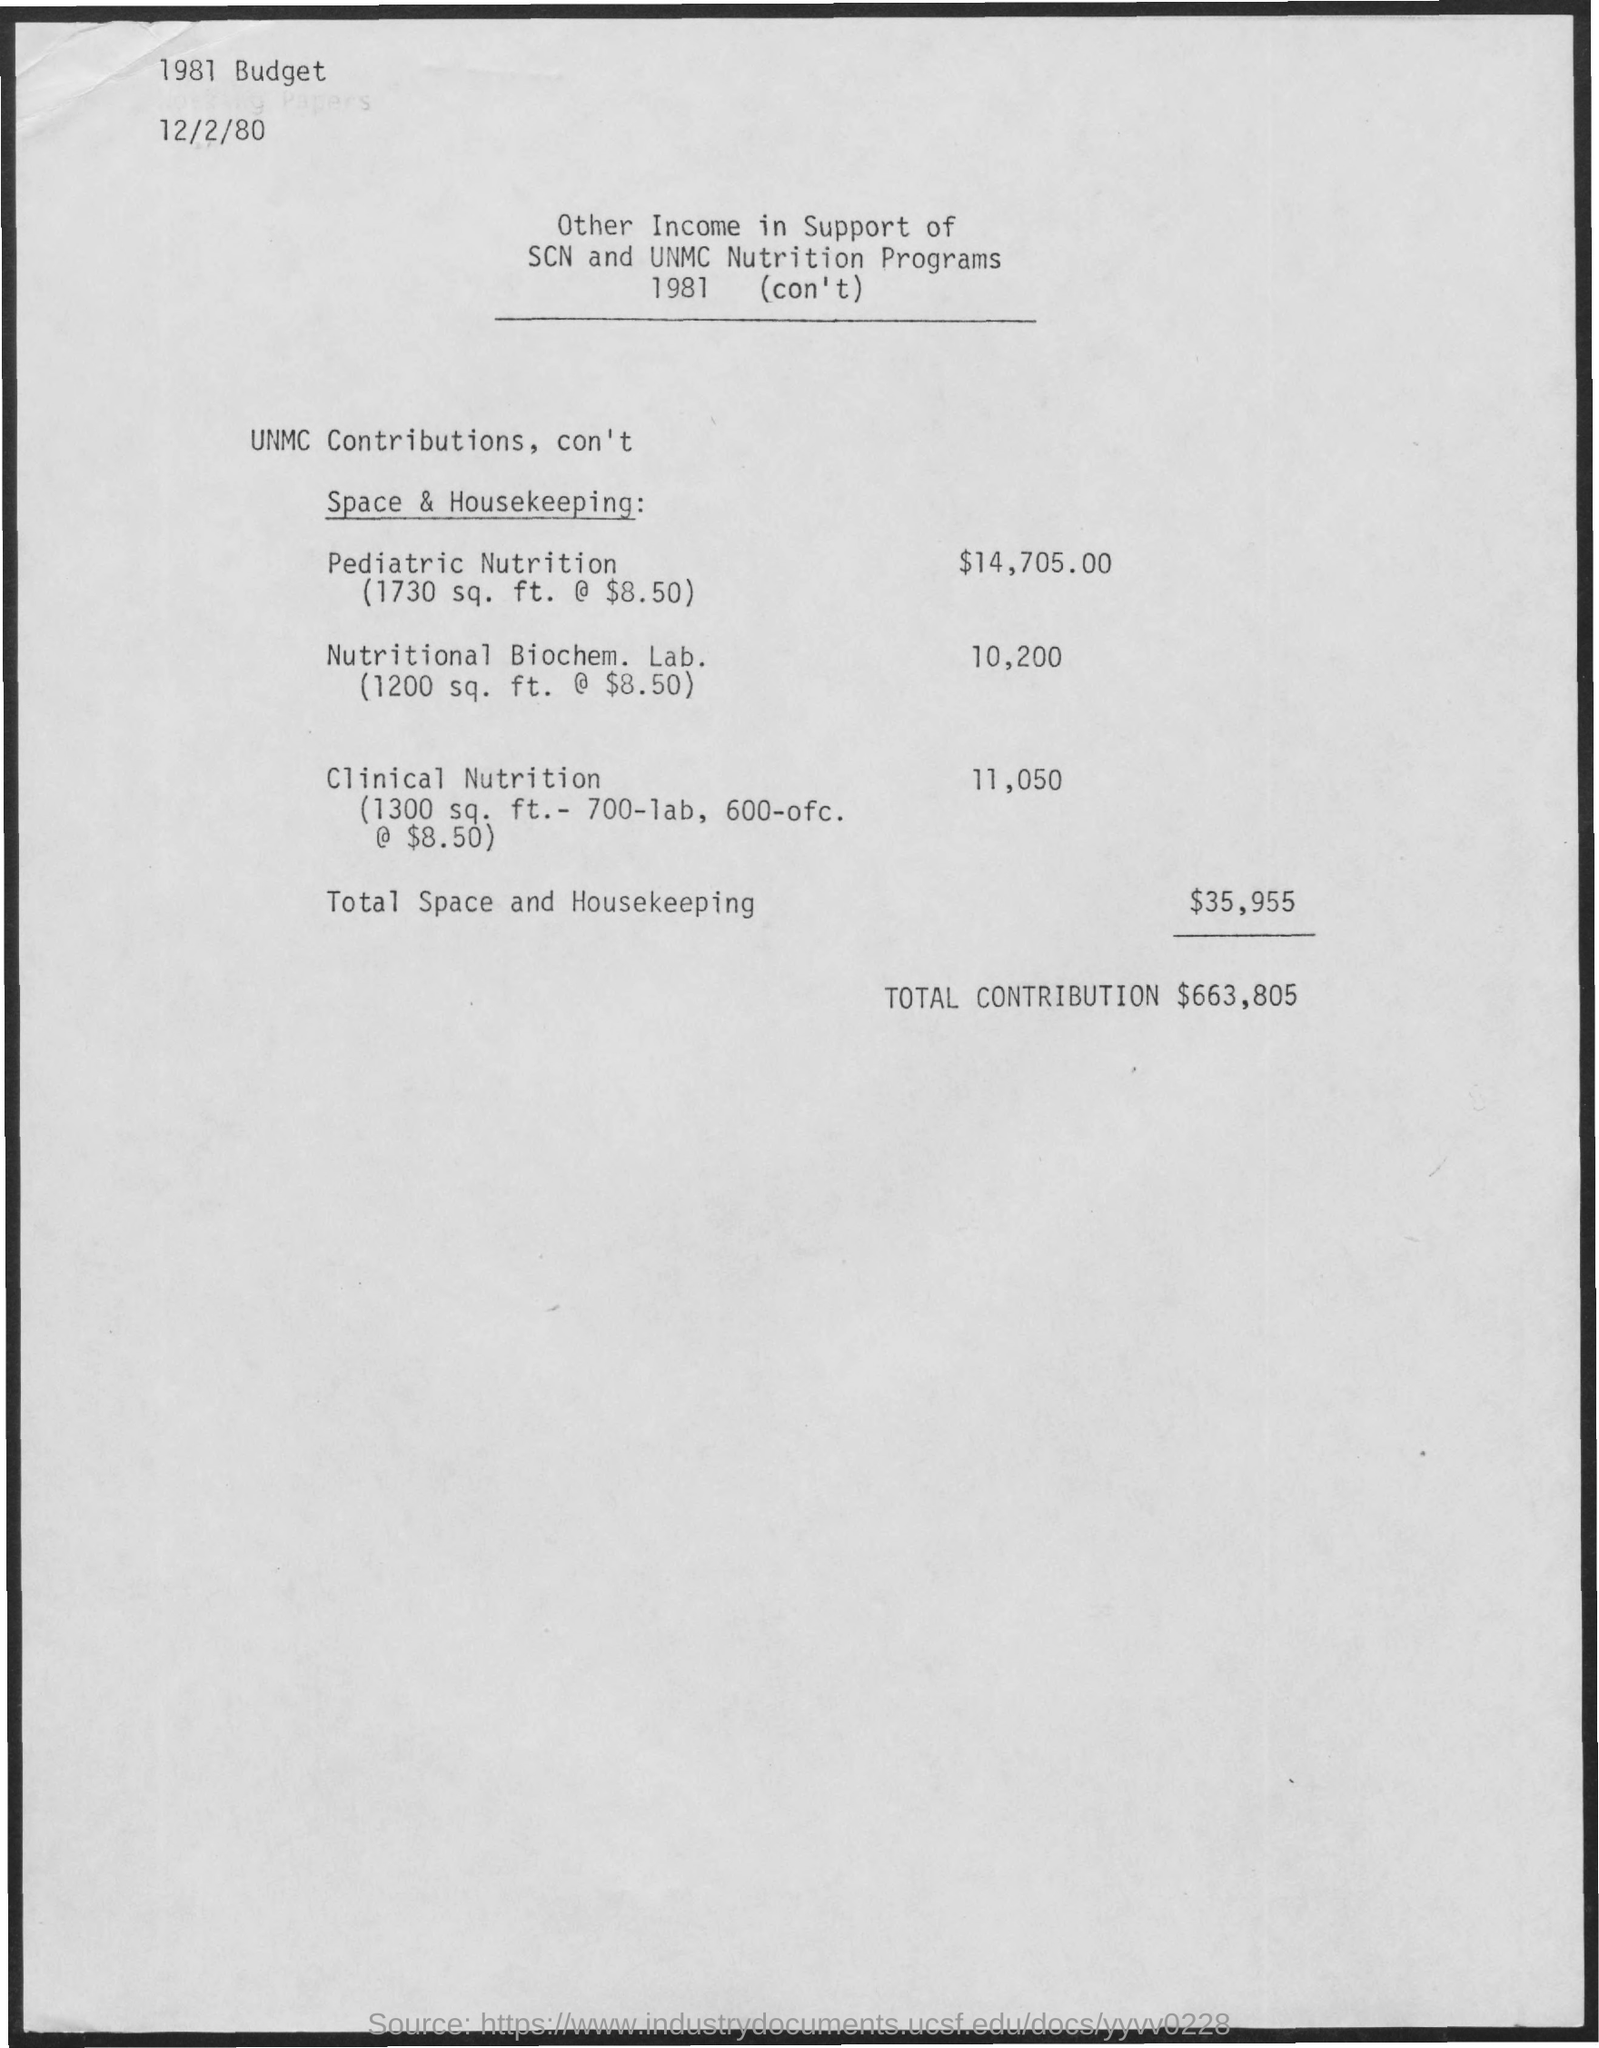What is the year of the budget mentioned in the top left corner of the page ?
Your answer should be compact. 1981. What is the date on the top of the page?
Offer a terse response. 12/2/80. What is the total income received from ' space and housekeeping ' ?
Offer a very short reply. $35,955. What is the area (in sq. ft.) covered by 'pediatric nutrition ' ?
Provide a succinct answer. 1730 sq. ft. What is the income contributed by the 'Nutritional Biochem. lab. '?
Keep it short and to the point. 10,200. 